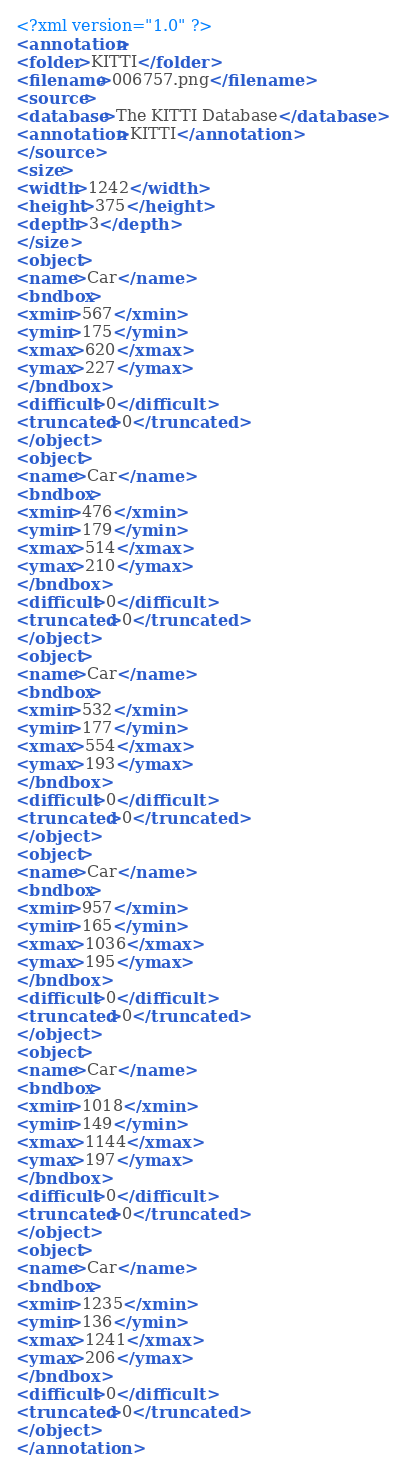<code> <loc_0><loc_0><loc_500><loc_500><_XML_><?xml version="1.0" ?>
<annotation>
<folder>KITTI</folder>
<filename>006757.png</filename>
<source>
<database>The KITTI Database</database>
<annotation>KITTI</annotation>
</source>
<size>
<width>1242</width>
<height>375</height>
<depth>3</depth>
</size>
<object>
<name>Car</name>
<bndbox>
<xmin>567</xmin>
<ymin>175</ymin>
<xmax>620</xmax>
<ymax>227</ymax>
</bndbox>
<difficult>0</difficult>
<truncated>0</truncated>
</object>
<object>
<name>Car</name>
<bndbox>
<xmin>476</xmin>
<ymin>179</ymin>
<xmax>514</xmax>
<ymax>210</ymax>
</bndbox>
<difficult>0</difficult>
<truncated>0</truncated>
</object>
<object>
<name>Car</name>
<bndbox>
<xmin>532</xmin>
<ymin>177</ymin>
<xmax>554</xmax>
<ymax>193</ymax>
</bndbox>
<difficult>0</difficult>
<truncated>0</truncated>
</object>
<object>
<name>Car</name>
<bndbox>
<xmin>957</xmin>
<ymin>165</ymin>
<xmax>1036</xmax>
<ymax>195</ymax>
</bndbox>
<difficult>0</difficult>
<truncated>0</truncated>
</object>
<object>
<name>Car</name>
<bndbox>
<xmin>1018</xmin>
<ymin>149</ymin>
<xmax>1144</xmax>
<ymax>197</ymax>
</bndbox>
<difficult>0</difficult>
<truncated>0</truncated>
</object>
<object>
<name>Car</name>
<bndbox>
<xmin>1235</xmin>
<ymin>136</ymin>
<xmax>1241</xmax>
<ymax>206</ymax>
</bndbox>
<difficult>0</difficult>
<truncated>0</truncated>
</object>
</annotation>
</code> 